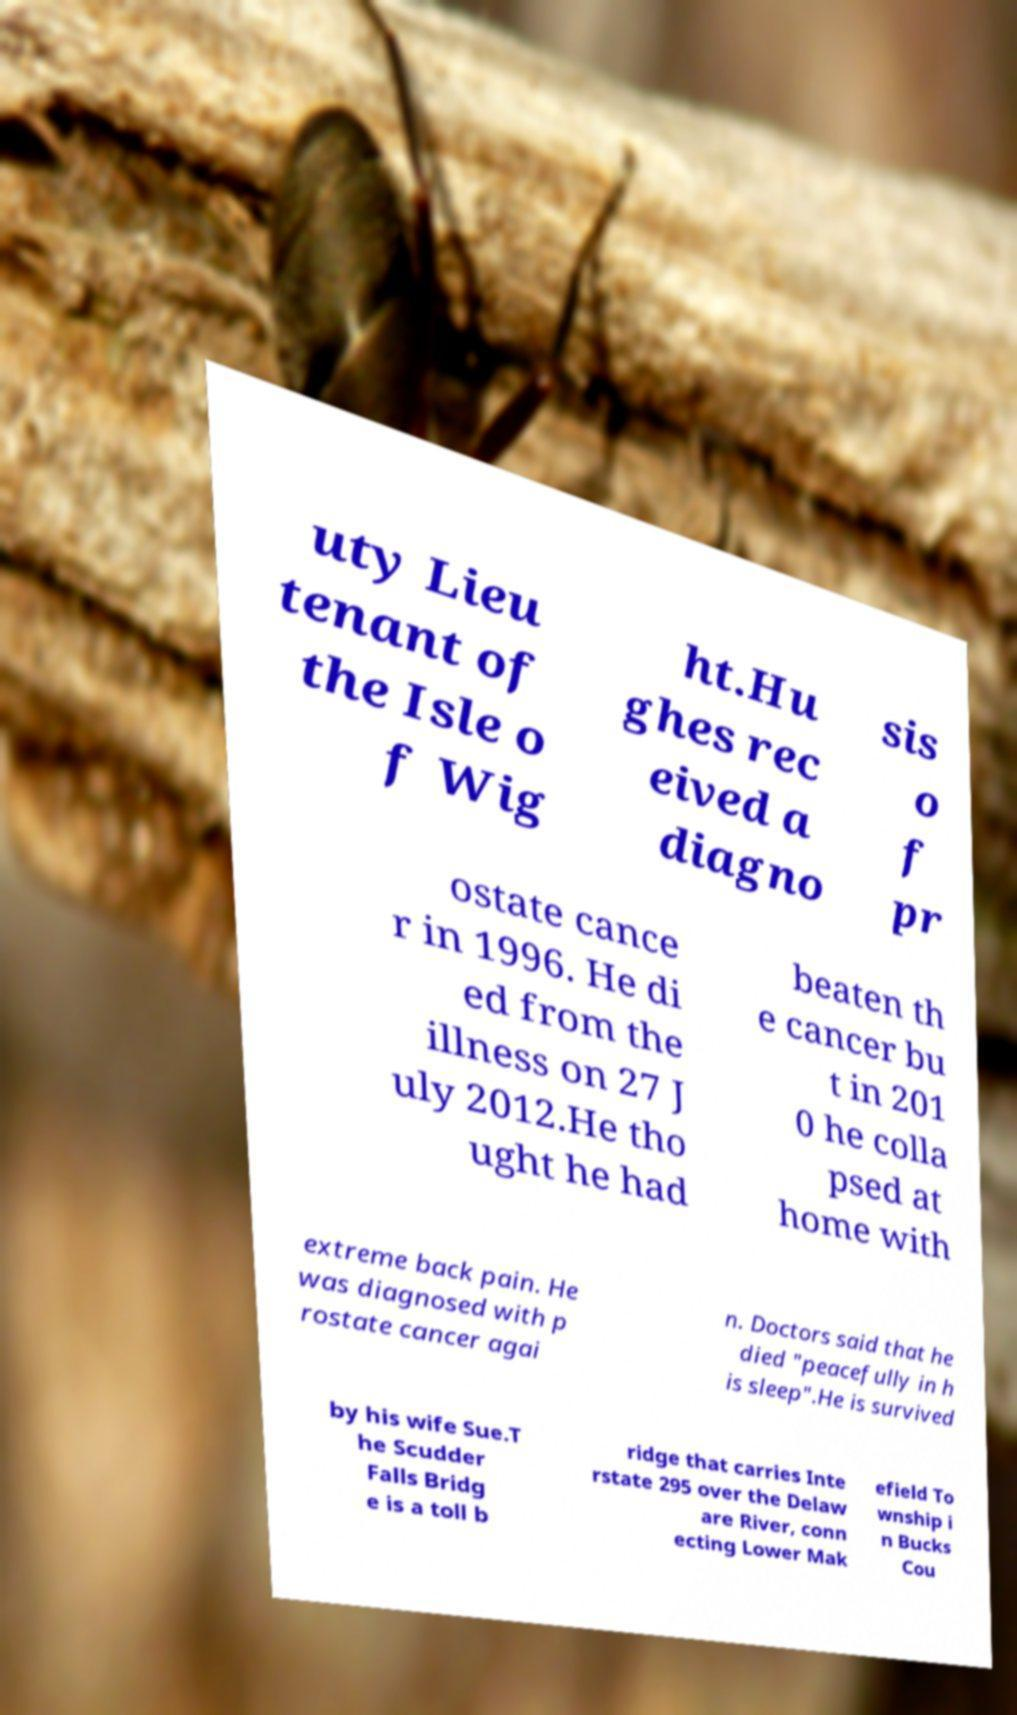There's text embedded in this image that I need extracted. Can you transcribe it verbatim? uty Lieu tenant of the Isle o f Wig ht.Hu ghes rec eived a diagno sis o f pr ostate cance r in 1996. He di ed from the illness on 27 J uly 2012.He tho ught he had beaten th e cancer bu t in 201 0 he colla psed at home with extreme back pain. He was diagnosed with p rostate cancer agai n. Doctors said that he died "peacefully in h is sleep".He is survived by his wife Sue.T he Scudder Falls Bridg e is a toll b ridge that carries Inte rstate 295 over the Delaw are River, conn ecting Lower Mak efield To wnship i n Bucks Cou 